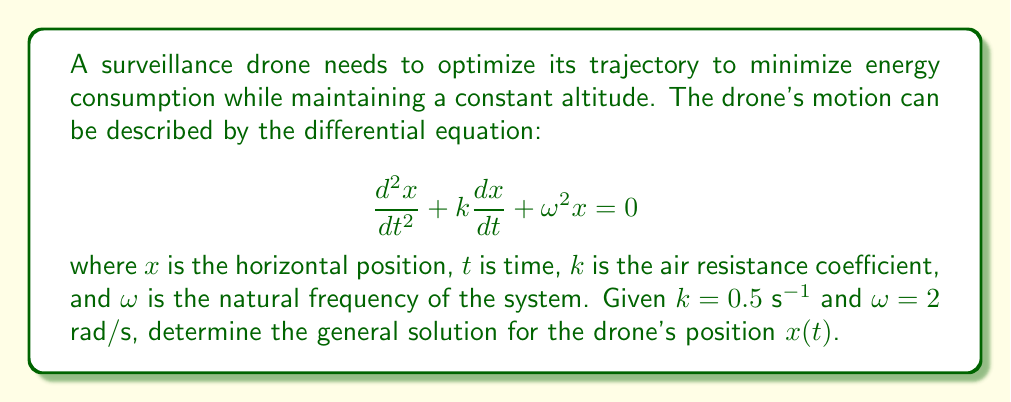Solve this math problem. To solve this second-order linear differential equation, we follow these steps:

1) The characteristic equation for this differential equation is:
   $$r^2 + kr + \omega^2 = 0$$

2) Substituting the given values $k = 0.5$ and $\omega = 2$:
   $$r^2 + 0.5r + 4 = 0$$

3) Solve this quadratic equation using the quadratic formula:
   $$r = \frac{-b \pm \sqrt{b^2 - 4ac}}{2a}$$
   $$r = \frac{-0.5 \pm \sqrt{0.5^2 - 4(1)(4)}}{2(1)}$$
   $$r = \frac{-0.5 \pm \sqrt{0.25 - 16}}{2}$$
   $$r = \frac{-0.5 \pm \sqrt{-15.75}}{2}$$

4) This gives us complex roots:
   $$r = -0.25 \pm i\sqrt{3.9375}$$

5) We can approximate this as:
   $$r \approx -0.25 \pm 1.984i$$

6) The general solution for a second-order linear differential equation with complex roots is:
   $$x(t) = e^{at}(C_1\cos(bt) + C_2\sin(bt))$$
   where $a$ is the real part and $b$ is the imaginary part of the roots.

7) Therefore, the general solution is:
   $$x(t) = e^{-0.25t}(C_1\cos(1.984t) + C_2\sin(1.984t))$$

where $C_1$ and $C_2$ are arbitrary constants determined by initial conditions.
Answer: $x(t) = e^{-0.25t}(C_1\cos(1.984t) + C_2\sin(1.984t))$ 